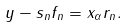Convert formula to latex. <formula><loc_0><loc_0><loc_500><loc_500>y - s _ { n } f _ { n } = x _ { \alpha } r _ { n } .</formula> 